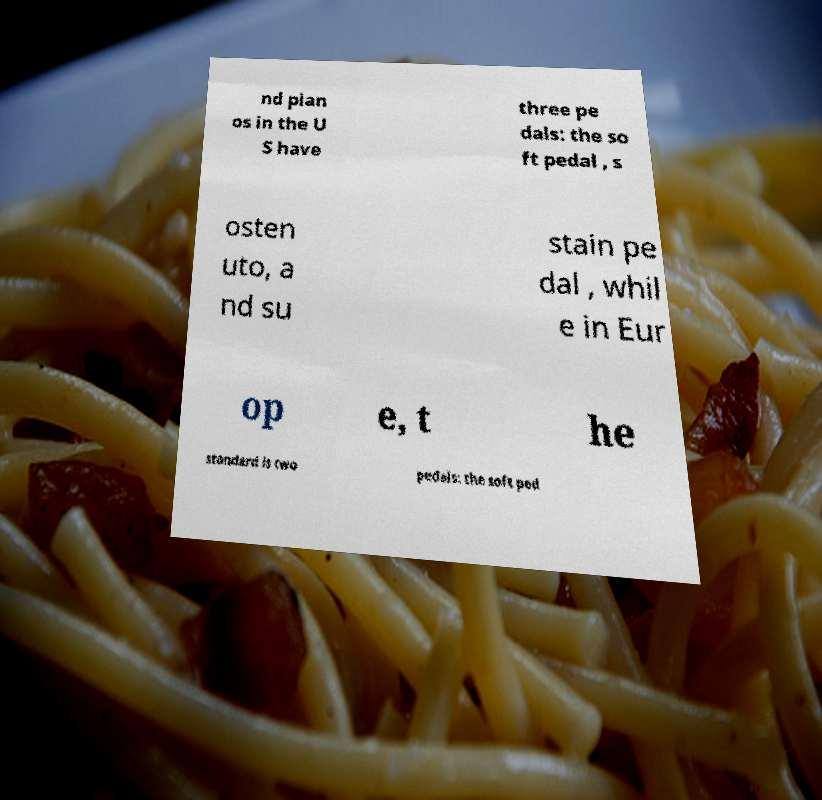There's text embedded in this image that I need extracted. Can you transcribe it verbatim? nd pian os in the U S have three pe dals: the so ft pedal , s osten uto, a nd su stain pe dal , whil e in Eur op e, t he standard is two pedals: the soft ped 